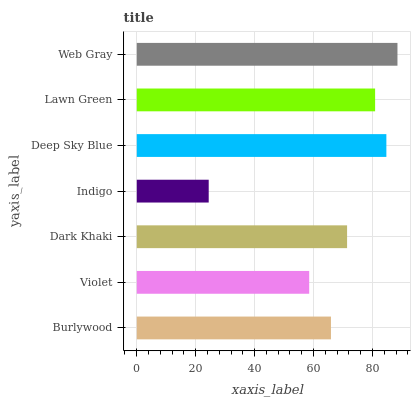Is Indigo the minimum?
Answer yes or no. Yes. Is Web Gray the maximum?
Answer yes or no. Yes. Is Violet the minimum?
Answer yes or no. No. Is Violet the maximum?
Answer yes or no. No. Is Burlywood greater than Violet?
Answer yes or no. Yes. Is Violet less than Burlywood?
Answer yes or no. Yes. Is Violet greater than Burlywood?
Answer yes or no. No. Is Burlywood less than Violet?
Answer yes or no. No. Is Dark Khaki the high median?
Answer yes or no. Yes. Is Dark Khaki the low median?
Answer yes or no. Yes. Is Lawn Green the high median?
Answer yes or no. No. Is Indigo the low median?
Answer yes or no. No. 